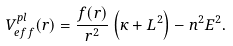<formula> <loc_0><loc_0><loc_500><loc_500>V ^ { p l } _ { e f f } ( r ) = \frac { f ( r ) } { r ^ { 2 } } \left ( \kappa + L ^ { 2 } \right ) - n ^ { 2 } E ^ { 2 } .</formula> 